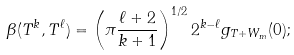<formula> <loc_0><loc_0><loc_500><loc_500>\beta ( T ^ { k } , T ^ { \ell } ) = \left ( \pi \frac { \ell + 2 } { k + 1 } \right ) ^ { 1 / 2 } 2 ^ { k - \ell } g _ { T + W _ { m } } ( 0 ) ;</formula> 